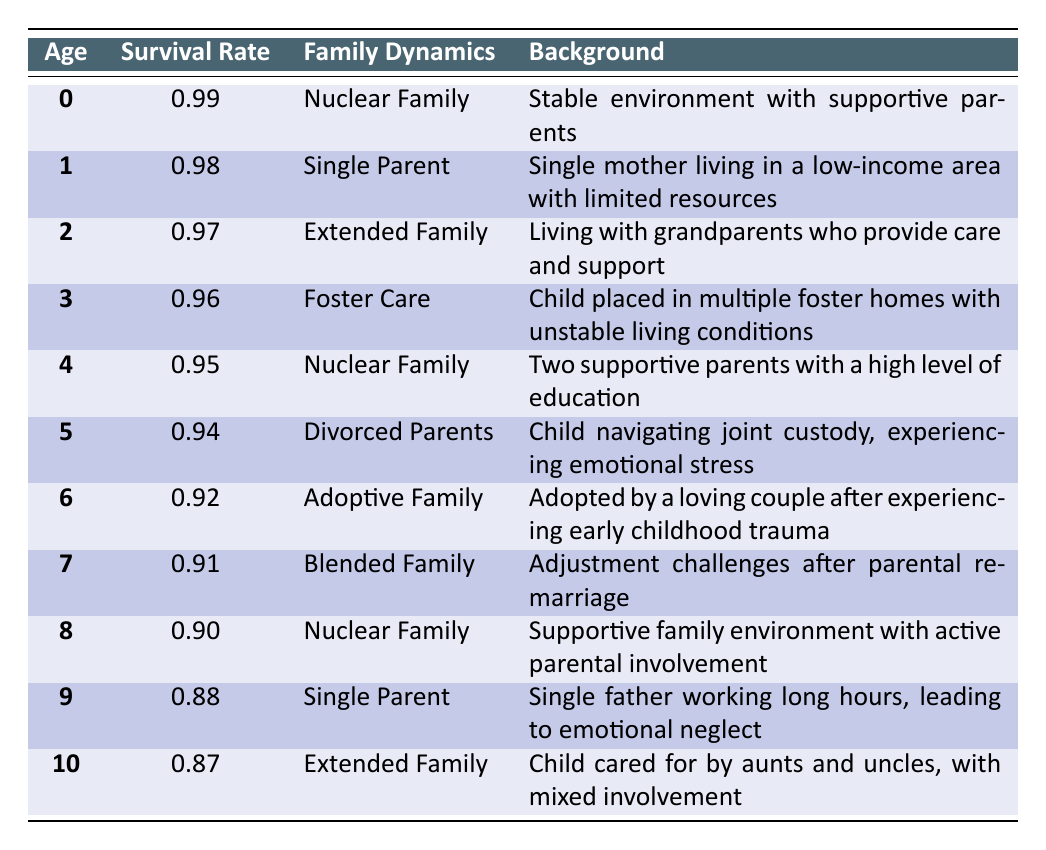What is the survival rate for children aged 5? From the table, the survival rate for children aged 5 is listed as 0.94.
Answer: 0.94 How does the survival rate of children in foster care (age 3) compare to those in a nuclear family (age 0)? The survival rate for children in foster care (age 3) is 0.96, while the survival rate for children in a nuclear family (age 0) is 0.99. 0.99 is greater than 0.96, meaning children in a nuclear family have a higher survival rate.
Answer: 0.99 is higher than 0.96 Is the survival rate for children raised by single parents higher or lower than those raised by blended families? The survival rates for single parents (age 1 at 0.98 and age 9 at 0.88) are compared to blended families (age 7 at 0.91). The average survival rate for single parent families is (0.98 + 0.88)/2 = 0.93, which is lower than the rate for blended families at 0.91. Therefore, single parent families have lower survival rates.
Answer: Lower What is the average survival rate for children aged 0 to 4? The survival rates for ages 0 to 4 are 0.99, 0.98, 0.97, 0.96, and 0.95. To find the average, we sum these values: 0.99 + 0.98 + 0.97 + 0.96 + 0.95 = 4.85. There are 5 data points, so we divide 4.85 by 5, resulting in an average survival rate of 0.97.
Answer: 0.97 Do children in nuclear families always have the highest survival rates according to the table? At age 0 and age 4, children in nuclear families have the highest survival rates of 0.99 and 0.95 respectively. However, at other ages (e.g., age 8 at 0.90), the survival rate is lower than those in a single parent arrangement (age 1). Thus, it's not true that nuclear families always have the highest survival rates.
Answer: No What is the survival rate trend as children age from 0 to 10 in the extended family category? The survival rates for the extended family category at ages 2 and 10 are 0.97 and 0.87 respectively. To analyze the trend, we note that it decreases from 0.97 to 0.87 as the age increases. This shows a downward trend in survival rates for children in extended families as they age.
Answer: Decreasing trend 